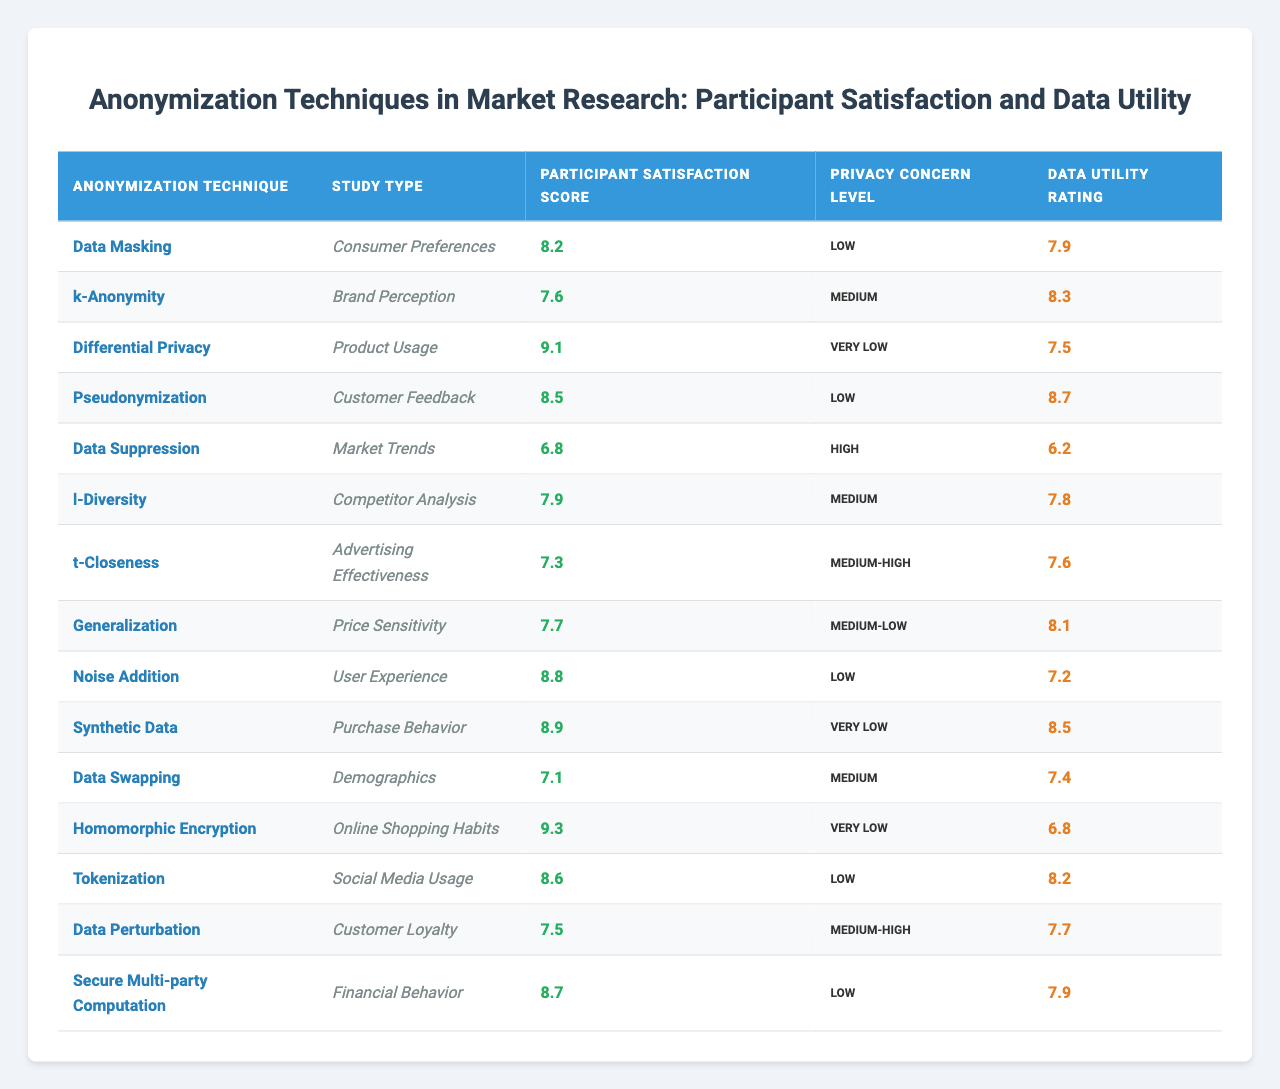What is the participant satisfaction score for Differential Privacy? The table shows that the satisfaction score for Differential Privacy is listed under the "Participant Satisfaction Score" column. Looking at the row for Differential Privacy, it shows a score of 9.1.
Answer: 9.1 Which anonymization technique has the highest participant satisfaction score? By comparing all the satisfaction scores in the table, we can see that Differential Privacy has the highest score of 9.1.
Answer: Differential Privacy What is the average participant satisfaction score for the techniques that have a low privacy concern level? The techniques with a low privacy concern level are Data Masking, Pseudonymization, Noise Addition, Synthetic Data, Tokenization, and Secure Multi-party Computation. Their scores are 8.2, 8.5, 8.8, 8.9, 8.6, and 8.7, respectively. The sum is 51.7, and the average is 51.7 divided by 6, which equals approximately 8.62.
Answer: 8.62 Is the participant satisfaction score higher for techniques with very low privacy concern compared to those with high privacy concern? Techniques with very low privacy concern are Differential Privacy, Synthetic Data, and Homomorphic Encryption, with scores of 9.1, 8.9, and 9.3, respectively, averaging to approximately 9.1. The only technique with a high privacy concern, Data Suppression, has a score of 6.8. Since 9.1 is greater than 6.8, the statement is true.
Answer: Yes What is the difference in participant satisfaction scores between k-Anonymity and Data Masking? The satisfaction score for k-Anonymity is 7.6 and for Data Masking is 8.2. To find the difference, we subtract 7.6 from 8.2, which equals 0.6.
Answer: 0.6 Which study type associated with the technique "Data Swapping" has the lowest Data Utility Rating? The Data Utility Rating for Data Swapping is 7.4. To find if this is the lowest, we can check the ratings for all other techniques. Data Suppression has the lowest rating at 6.2, thus Data Swapping does not have the lowest rating.
Answer: No How many anonymization techniques have a participant satisfaction score above 8? By reviewing the satisfaction scores, we find that the following techniques have scores above 8: Differential Privacy (9.1), Synthetic Data (8.9), Homomorphic Encryption (9.3), Noise Addition (8.8), Pseudonymization (8.5), and Secure Multi-party Computation (8.7). In total, there are 6 techniques.
Answer: 6 What are the privacy concern levels for all techniques with a participant satisfaction score under 7.5? The techniques with scores under 7.5 are Data Suppression (6.8), Data Swapping (7.1), and Data Perturbation (7.5). Their corresponding privacy concern levels are High, Medium, and Medium-High, respectively.
Answer: High, Medium, Medium-High Is there a correlation between privacy concern level and satisfaction score in this table? To investigate a correlation, we can observe if techniques with lower privacy concerns show higher satisfaction. Techniques with Very Low privacy concerns like Differential Privacy and Homomorphic Encryption have high scores (9.1 and 9.3), while the technique with High concern, Data Suppression, has a low score (6.8). This suggests a tendency that as privacy concerns decrease, satisfaction scores may increase.
Answer: Yes 